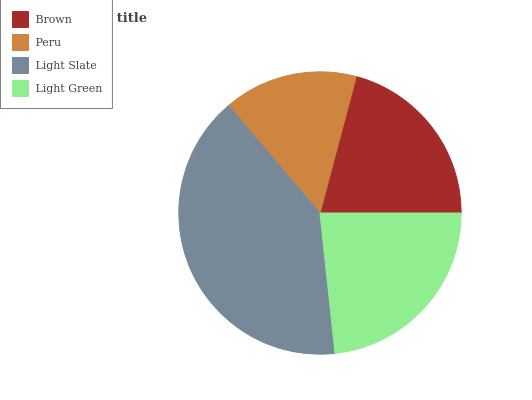Is Peru the minimum?
Answer yes or no. Yes. Is Light Slate the maximum?
Answer yes or no. Yes. Is Light Slate the minimum?
Answer yes or no. No. Is Peru the maximum?
Answer yes or no. No. Is Light Slate greater than Peru?
Answer yes or no. Yes. Is Peru less than Light Slate?
Answer yes or no. Yes. Is Peru greater than Light Slate?
Answer yes or no. No. Is Light Slate less than Peru?
Answer yes or no. No. Is Light Green the high median?
Answer yes or no. Yes. Is Brown the low median?
Answer yes or no. Yes. Is Light Slate the high median?
Answer yes or no. No. Is Peru the low median?
Answer yes or no. No. 